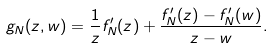Convert formula to latex. <formula><loc_0><loc_0><loc_500><loc_500>g _ { N } ( z , w ) = \frac { 1 } { z } f _ { N } ^ { \prime } ( z ) + \frac { f _ { N } ^ { \prime } ( z ) - f _ { N } ^ { \prime } ( w ) } { z - w } .</formula> 